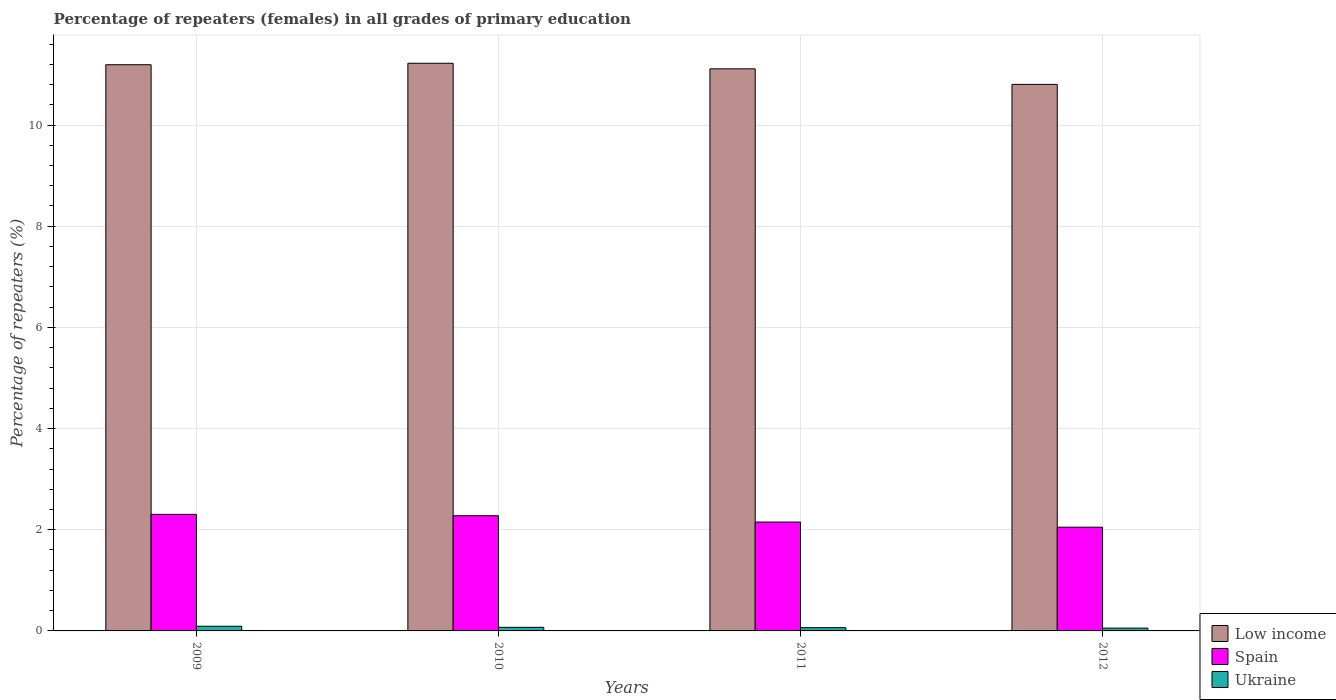How many groups of bars are there?
Your answer should be very brief. 4. Are the number of bars on each tick of the X-axis equal?
Make the answer very short. Yes. How many bars are there on the 2nd tick from the left?
Your answer should be compact. 3. How many bars are there on the 3rd tick from the right?
Give a very brief answer. 3. What is the percentage of repeaters (females) in Spain in 2012?
Offer a terse response. 2.05. Across all years, what is the maximum percentage of repeaters (females) in Low income?
Ensure brevity in your answer.  11.22. Across all years, what is the minimum percentage of repeaters (females) in Spain?
Provide a short and direct response. 2.05. In which year was the percentage of repeaters (females) in Low income maximum?
Make the answer very short. 2010. In which year was the percentage of repeaters (females) in Ukraine minimum?
Offer a terse response. 2012. What is the total percentage of repeaters (females) in Spain in the graph?
Provide a short and direct response. 8.78. What is the difference between the percentage of repeaters (females) in Spain in 2010 and that in 2011?
Your answer should be compact. 0.13. What is the difference between the percentage of repeaters (females) in Spain in 2009 and the percentage of repeaters (females) in Low income in 2012?
Offer a very short reply. -8.5. What is the average percentage of repeaters (females) in Ukraine per year?
Provide a succinct answer. 0.07. In the year 2012, what is the difference between the percentage of repeaters (females) in Low income and percentage of repeaters (females) in Ukraine?
Your response must be concise. 10.75. In how many years, is the percentage of repeaters (females) in Ukraine greater than 2.8 %?
Offer a very short reply. 0. What is the ratio of the percentage of repeaters (females) in Spain in 2010 to that in 2011?
Your response must be concise. 1.06. What is the difference between the highest and the second highest percentage of repeaters (females) in Spain?
Ensure brevity in your answer.  0.03. What is the difference between the highest and the lowest percentage of repeaters (females) in Spain?
Give a very brief answer. 0.25. Is the sum of the percentage of repeaters (females) in Low income in 2009 and 2010 greater than the maximum percentage of repeaters (females) in Ukraine across all years?
Provide a succinct answer. Yes. What does the 1st bar from the left in 2009 represents?
Provide a succinct answer. Low income. What does the 1st bar from the right in 2009 represents?
Give a very brief answer. Ukraine. Is it the case that in every year, the sum of the percentage of repeaters (females) in Ukraine and percentage of repeaters (females) in Low income is greater than the percentage of repeaters (females) in Spain?
Provide a succinct answer. Yes. What is the difference between two consecutive major ticks on the Y-axis?
Your response must be concise. 2. Are the values on the major ticks of Y-axis written in scientific E-notation?
Ensure brevity in your answer.  No. Does the graph contain any zero values?
Keep it short and to the point. No. Does the graph contain grids?
Provide a succinct answer. Yes. What is the title of the graph?
Your answer should be very brief. Percentage of repeaters (females) in all grades of primary education. Does "Iraq" appear as one of the legend labels in the graph?
Offer a very short reply. No. What is the label or title of the Y-axis?
Keep it short and to the point. Percentage of repeaters (%). What is the Percentage of repeaters (%) in Low income in 2009?
Your response must be concise. 11.19. What is the Percentage of repeaters (%) of Spain in 2009?
Ensure brevity in your answer.  2.3. What is the Percentage of repeaters (%) of Ukraine in 2009?
Give a very brief answer. 0.09. What is the Percentage of repeaters (%) of Low income in 2010?
Keep it short and to the point. 11.22. What is the Percentage of repeaters (%) of Spain in 2010?
Offer a very short reply. 2.28. What is the Percentage of repeaters (%) of Ukraine in 2010?
Your response must be concise. 0.07. What is the Percentage of repeaters (%) of Low income in 2011?
Give a very brief answer. 11.11. What is the Percentage of repeaters (%) in Spain in 2011?
Keep it short and to the point. 2.15. What is the Percentage of repeaters (%) in Ukraine in 2011?
Your response must be concise. 0.06. What is the Percentage of repeaters (%) of Low income in 2012?
Your response must be concise. 10.8. What is the Percentage of repeaters (%) in Spain in 2012?
Your answer should be compact. 2.05. What is the Percentage of repeaters (%) in Ukraine in 2012?
Offer a terse response. 0.06. Across all years, what is the maximum Percentage of repeaters (%) of Low income?
Offer a terse response. 11.22. Across all years, what is the maximum Percentage of repeaters (%) of Spain?
Your answer should be very brief. 2.3. Across all years, what is the maximum Percentage of repeaters (%) of Ukraine?
Provide a short and direct response. 0.09. Across all years, what is the minimum Percentage of repeaters (%) of Low income?
Make the answer very short. 10.8. Across all years, what is the minimum Percentage of repeaters (%) in Spain?
Give a very brief answer. 2.05. Across all years, what is the minimum Percentage of repeaters (%) of Ukraine?
Give a very brief answer. 0.06. What is the total Percentage of repeaters (%) of Low income in the graph?
Your response must be concise. 44.33. What is the total Percentage of repeaters (%) of Spain in the graph?
Provide a short and direct response. 8.78. What is the total Percentage of repeaters (%) in Ukraine in the graph?
Ensure brevity in your answer.  0.28. What is the difference between the Percentage of repeaters (%) in Low income in 2009 and that in 2010?
Your answer should be compact. -0.03. What is the difference between the Percentage of repeaters (%) in Spain in 2009 and that in 2010?
Your response must be concise. 0.03. What is the difference between the Percentage of repeaters (%) in Ukraine in 2009 and that in 2010?
Your response must be concise. 0.02. What is the difference between the Percentage of repeaters (%) in Low income in 2009 and that in 2011?
Ensure brevity in your answer.  0.08. What is the difference between the Percentage of repeaters (%) of Spain in 2009 and that in 2011?
Offer a terse response. 0.15. What is the difference between the Percentage of repeaters (%) of Ukraine in 2009 and that in 2011?
Ensure brevity in your answer.  0.03. What is the difference between the Percentage of repeaters (%) in Low income in 2009 and that in 2012?
Ensure brevity in your answer.  0.39. What is the difference between the Percentage of repeaters (%) of Spain in 2009 and that in 2012?
Ensure brevity in your answer.  0.25. What is the difference between the Percentage of repeaters (%) of Ukraine in 2009 and that in 2012?
Your answer should be very brief. 0.04. What is the difference between the Percentage of repeaters (%) in Low income in 2010 and that in 2011?
Provide a succinct answer. 0.11. What is the difference between the Percentage of repeaters (%) in Spain in 2010 and that in 2011?
Keep it short and to the point. 0.13. What is the difference between the Percentage of repeaters (%) of Ukraine in 2010 and that in 2011?
Your answer should be very brief. 0.01. What is the difference between the Percentage of repeaters (%) of Low income in 2010 and that in 2012?
Ensure brevity in your answer.  0.42. What is the difference between the Percentage of repeaters (%) of Spain in 2010 and that in 2012?
Provide a succinct answer. 0.23. What is the difference between the Percentage of repeaters (%) of Ukraine in 2010 and that in 2012?
Make the answer very short. 0.02. What is the difference between the Percentage of repeaters (%) in Low income in 2011 and that in 2012?
Keep it short and to the point. 0.31. What is the difference between the Percentage of repeaters (%) in Spain in 2011 and that in 2012?
Give a very brief answer. 0.1. What is the difference between the Percentage of repeaters (%) in Ukraine in 2011 and that in 2012?
Offer a terse response. 0.01. What is the difference between the Percentage of repeaters (%) of Low income in 2009 and the Percentage of repeaters (%) of Spain in 2010?
Give a very brief answer. 8.92. What is the difference between the Percentage of repeaters (%) in Low income in 2009 and the Percentage of repeaters (%) in Ukraine in 2010?
Offer a terse response. 11.12. What is the difference between the Percentage of repeaters (%) of Spain in 2009 and the Percentage of repeaters (%) of Ukraine in 2010?
Keep it short and to the point. 2.23. What is the difference between the Percentage of repeaters (%) in Low income in 2009 and the Percentage of repeaters (%) in Spain in 2011?
Ensure brevity in your answer.  9.04. What is the difference between the Percentage of repeaters (%) in Low income in 2009 and the Percentage of repeaters (%) in Ukraine in 2011?
Provide a short and direct response. 11.13. What is the difference between the Percentage of repeaters (%) in Spain in 2009 and the Percentage of repeaters (%) in Ukraine in 2011?
Make the answer very short. 2.24. What is the difference between the Percentage of repeaters (%) in Low income in 2009 and the Percentage of repeaters (%) in Spain in 2012?
Offer a very short reply. 9.14. What is the difference between the Percentage of repeaters (%) of Low income in 2009 and the Percentage of repeaters (%) of Ukraine in 2012?
Provide a succinct answer. 11.14. What is the difference between the Percentage of repeaters (%) of Spain in 2009 and the Percentage of repeaters (%) of Ukraine in 2012?
Your answer should be compact. 2.25. What is the difference between the Percentage of repeaters (%) of Low income in 2010 and the Percentage of repeaters (%) of Spain in 2011?
Your response must be concise. 9.07. What is the difference between the Percentage of repeaters (%) in Low income in 2010 and the Percentage of repeaters (%) in Ukraine in 2011?
Your answer should be very brief. 11.16. What is the difference between the Percentage of repeaters (%) of Spain in 2010 and the Percentage of repeaters (%) of Ukraine in 2011?
Provide a succinct answer. 2.21. What is the difference between the Percentage of repeaters (%) of Low income in 2010 and the Percentage of repeaters (%) of Spain in 2012?
Offer a terse response. 9.17. What is the difference between the Percentage of repeaters (%) in Low income in 2010 and the Percentage of repeaters (%) in Ukraine in 2012?
Provide a short and direct response. 11.17. What is the difference between the Percentage of repeaters (%) of Spain in 2010 and the Percentage of repeaters (%) of Ukraine in 2012?
Your response must be concise. 2.22. What is the difference between the Percentage of repeaters (%) of Low income in 2011 and the Percentage of repeaters (%) of Spain in 2012?
Provide a succinct answer. 9.06. What is the difference between the Percentage of repeaters (%) in Low income in 2011 and the Percentage of repeaters (%) in Ukraine in 2012?
Keep it short and to the point. 11.06. What is the difference between the Percentage of repeaters (%) in Spain in 2011 and the Percentage of repeaters (%) in Ukraine in 2012?
Your answer should be compact. 2.1. What is the average Percentage of repeaters (%) of Low income per year?
Your answer should be compact. 11.08. What is the average Percentage of repeaters (%) in Spain per year?
Ensure brevity in your answer.  2.2. What is the average Percentage of repeaters (%) in Ukraine per year?
Your answer should be very brief. 0.07. In the year 2009, what is the difference between the Percentage of repeaters (%) in Low income and Percentage of repeaters (%) in Spain?
Offer a very short reply. 8.89. In the year 2009, what is the difference between the Percentage of repeaters (%) of Low income and Percentage of repeaters (%) of Ukraine?
Ensure brevity in your answer.  11.1. In the year 2009, what is the difference between the Percentage of repeaters (%) in Spain and Percentage of repeaters (%) in Ukraine?
Your answer should be compact. 2.21. In the year 2010, what is the difference between the Percentage of repeaters (%) of Low income and Percentage of repeaters (%) of Spain?
Give a very brief answer. 8.94. In the year 2010, what is the difference between the Percentage of repeaters (%) in Low income and Percentage of repeaters (%) in Ukraine?
Provide a succinct answer. 11.15. In the year 2010, what is the difference between the Percentage of repeaters (%) in Spain and Percentage of repeaters (%) in Ukraine?
Keep it short and to the point. 2.21. In the year 2011, what is the difference between the Percentage of repeaters (%) in Low income and Percentage of repeaters (%) in Spain?
Ensure brevity in your answer.  8.96. In the year 2011, what is the difference between the Percentage of repeaters (%) of Low income and Percentage of repeaters (%) of Ukraine?
Keep it short and to the point. 11.05. In the year 2011, what is the difference between the Percentage of repeaters (%) in Spain and Percentage of repeaters (%) in Ukraine?
Your answer should be very brief. 2.09. In the year 2012, what is the difference between the Percentage of repeaters (%) in Low income and Percentage of repeaters (%) in Spain?
Ensure brevity in your answer.  8.75. In the year 2012, what is the difference between the Percentage of repeaters (%) in Low income and Percentage of repeaters (%) in Ukraine?
Provide a succinct answer. 10.75. In the year 2012, what is the difference between the Percentage of repeaters (%) of Spain and Percentage of repeaters (%) of Ukraine?
Offer a terse response. 2. What is the ratio of the Percentage of repeaters (%) of Low income in 2009 to that in 2010?
Provide a succinct answer. 1. What is the ratio of the Percentage of repeaters (%) in Spain in 2009 to that in 2010?
Offer a terse response. 1.01. What is the ratio of the Percentage of repeaters (%) of Ukraine in 2009 to that in 2010?
Ensure brevity in your answer.  1.3. What is the ratio of the Percentage of repeaters (%) in Low income in 2009 to that in 2011?
Provide a short and direct response. 1.01. What is the ratio of the Percentage of repeaters (%) in Spain in 2009 to that in 2011?
Give a very brief answer. 1.07. What is the ratio of the Percentage of repeaters (%) in Ukraine in 2009 to that in 2011?
Give a very brief answer. 1.45. What is the ratio of the Percentage of repeaters (%) of Low income in 2009 to that in 2012?
Provide a short and direct response. 1.04. What is the ratio of the Percentage of repeaters (%) of Spain in 2009 to that in 2012?
Provide a short and direct response. 1.12. What is the ratio of the Percentage of repeaters (%) in Ukraine in 2009 to that in 2012?
Your response must be concise. 1.66. What is the ratio of the Percentage of repeaters (%) of Low income in 2010 to that in 2011?
Offer a very short reply. 1.01. What is the ratio of the Percentage of repeaters (%) in Spain in 2010 to that in 2011?
Give a very brief answer. 1.06. What is the ratio of the Percentage of repeaters (%) of Ukraine in 2010 to that in 2011?
Keep it short and to the point. 1.11. What is the ratio of the Percentage of repeaters (%) in Low income in 2010 to that in 2012?
Ensure brevity in your answer.  1.04. What is the ratio of the Percentage of repeaters (%) of Spain in 2010 to that in 2012?
Keep it short and to the point. 1.11. What is the ratio of the Percentage of repeaters (%) of Ukraine in 2010 to that in 2012?
Ensure brevity in your answer.  1.27. What is the ratio of the Percentage of repeaters (%) in Low income in 2011 to that in 2012?
Make the answer very short. 1.03. What is the ratio of the Percentage of repeaters (%) of Spain in 2011 to that in 2012?
Offer a very short reply. 1.05. What is the ratio of the Percentage of repeaters (%) in Ukraine in 2011 to that in 2012?
Offer a terse response. 1.15. What is the difference between the highest and the second highest Percentage of repeaters (%) in Low income?
Offer a terse response. 0.03. What is the difference between the highest and the second highest Percentage of repeaters (%) in Spain?
Offer a very short reply. 0.03. What is the difference between the highest and the second highest Percentage of repeaters (%) in Ukraine?
Ensure brevity in your answer.  0.02. What is the difference between the highest and the lowest Percentage of repeaters (%) in Low income?
Your response must be concise. 0.42. What is the difference between the highest and the lowest Percentage of repeaters (%) of Spain?
Give a very brief answer. 0.25. What is the difference between the highest and the lowest Percentage of repeaters (%) of Ukraine?
Your answer should be compact. 0.04. 